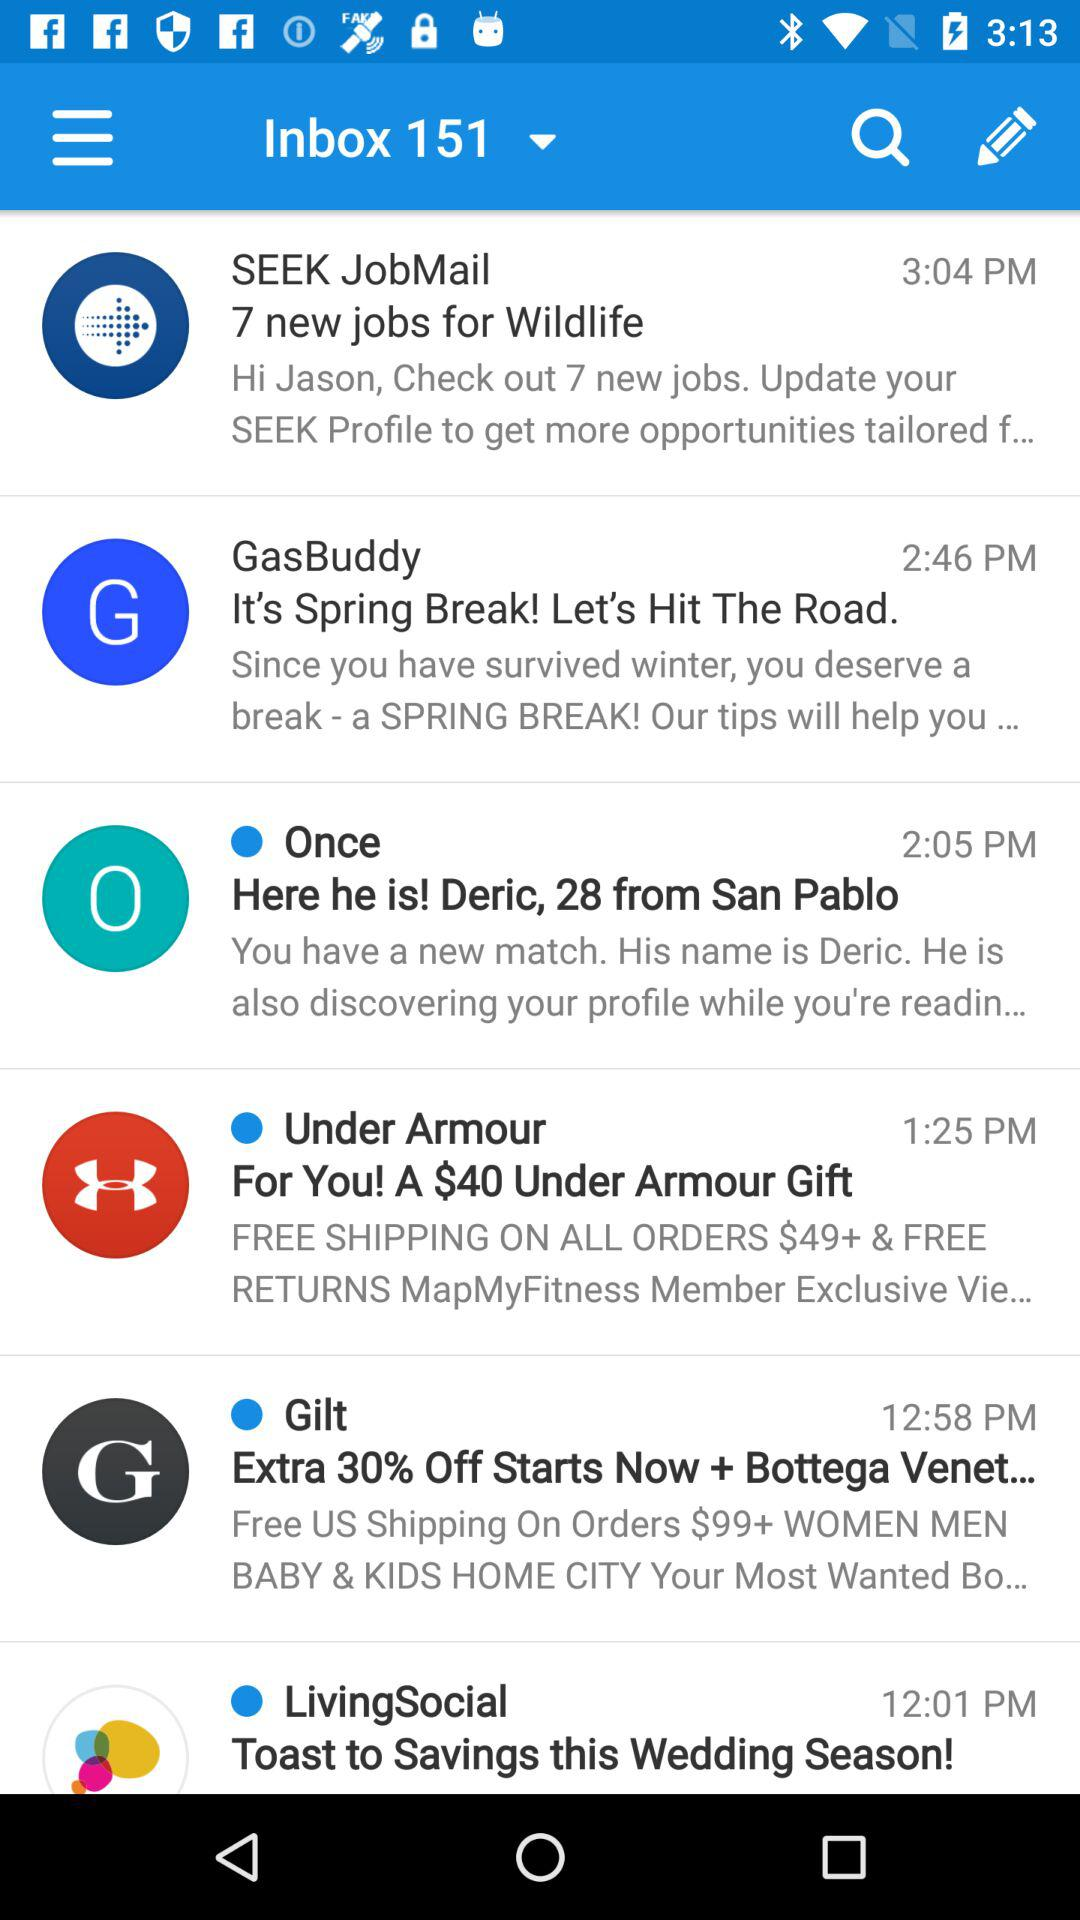How many new jobs are there for Wildlife?
Answer the question using a single word or phrase. 7 